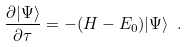<formula> <loc_0><loc_0><loc_500><loc_500>\frac { \partial | \Psi \rangle } { \partial \tau } = - ( H - E _ { 0 } ) | \Psi \rangle \ .</formula> 